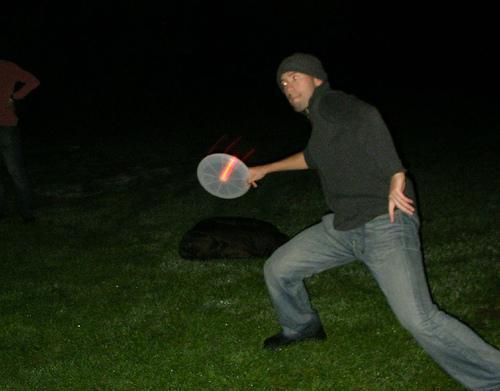How many men do you see?
Give a very brief answer. 1. How many frisbees are there?
Give a very brief answer. 1. How many people are wearing hats?
Give a very brief answer. 1. How many people are there?
Give a very brief answer. 2. How many black horse ?
Give a very brief answer. 0. 